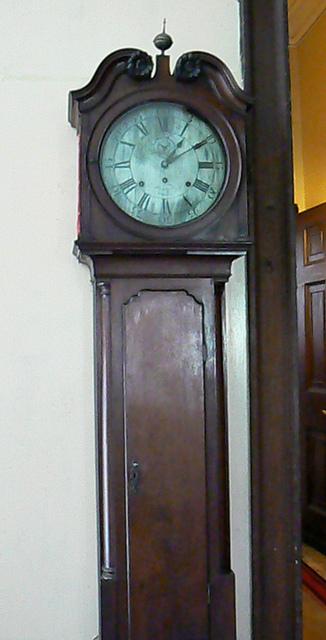What color is the clock?
Answer briefly. Brown. What time is on this clock?
Write a very short answer. 1:10. What color is the wall?
Short answer required. White. 